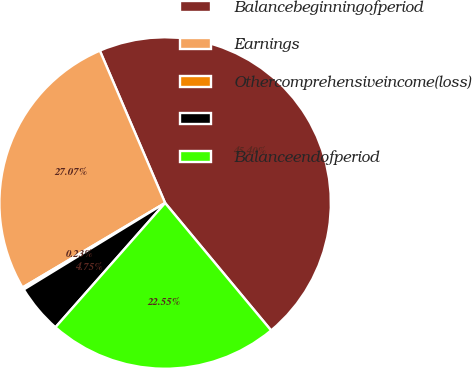<chart> <loc_0><loc_0><loc_500><loc_500><pie_chart><fcel>Balancebeginningofperiod<fcel>Earnings<fcel>Othercomprehensiveincome(loss)<fcel>Unnamed: 3<fcel>Balanceendofperiod<nl><fcel>45.4%<fcel>27.07%<fcel>0.23%<fcel>4.75%<fcel>22.55%<nl></chart> 